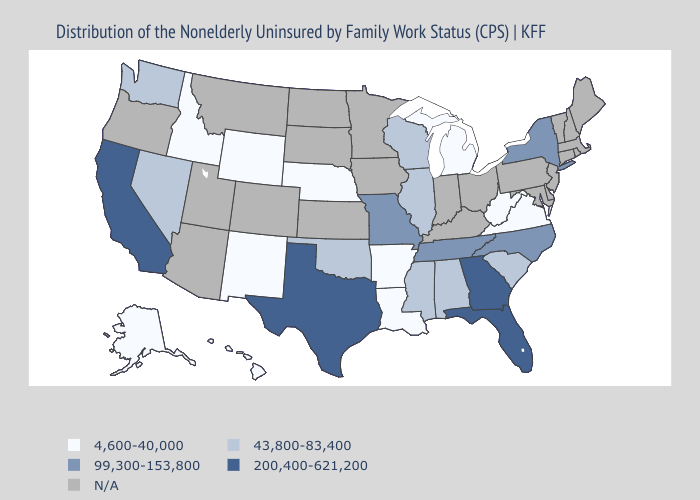Name the states that have a value in the range N/A?
Keep it brief. Arizona, Colorado, Connecticut, Delaware, Indiana, Iowa, Kansas, Kentucky, Maine, Maryland, Massachusetts, Minnesota, Montana, New Hampshire, New Jersey, North Dakota, Ohio, Oregon, Pennsylvania, Rhode Island, South Dakota, Utah, Vermont. What is the highest value in states that border New Mexico?
Answer briefly. 200,400-621,200. Among the states that border Nebraska , does Missouri have the lowest value?
Write a very short answer. No. Which states hav the highest value in the Northeast?
Answer briefly. New York. Name the states that have a value in the range 43,800-83,400?
Concise answer only. Alabama, Illinois, Mississippi, Nevada, Oklahoma, South Carolina, Washington, Wisconsin. Which states have the highest value in the USA?
Concise answer only. California, Florida, Georgia, Texas. What is the value of Michigan?
Concise answer only. 4,600-40,000. Name the states that have a value in the range N/A?
Short answer required. Arizona, Colorado, Connecticut, Delaware, Indiana, Iowa, Kansas, Kentucky, Maine, Maryland, Massachusetts, Minnesota, Montana, New Hampshire, New Jersey, North Dakota, Ohio, Oregon, Pennsylvania, Rhode Island, South Dakota, Utah, Vermont. Name the states that have a value in the range 43,800-83,400?
Quick response, please. Alabama, Illinois, Mississippi, Nevada, Oklahoma, South Carolina, Washington, Wisconsin. What is the lowest value in the Northeast?
Short answer required. 99,300-153,800. What is the value of Alaska?
Answer briefly. 4,600-40,000. What is the value of Hawaii?
Keep it brief. 4,600-40,000. Name the states that have a value in the range 4,600-40,000?
Short answer required. Alaska, Arkansas, Hawaii, Idaho, Louisiana, Michigan, Nebraska, New Mexico, Virginia, West Virginia, Wyoming. 